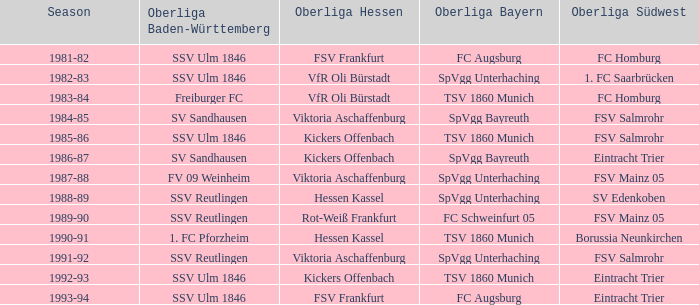Which oberliga baden-württemberg has a season of 1991-92? SSV Reutlingen. 